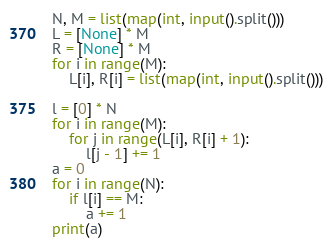Convert code to text. <code><loc_0><loc_0><loc_500><loc_500><_Python_>N, M = list(map(int, input().split()))
L = [None] * M
R = [None] * M
for i in range(M):
    L[i], R[i] = list(map(int, input().split()))

l = [0] * N
for i in range(M):
    for j in range(L[i], R[i] + 1):
        l[j - 1] += 1
a = 0
for i in range(N):
    if l[i] == M:
        a += 1
print(a)</code> 